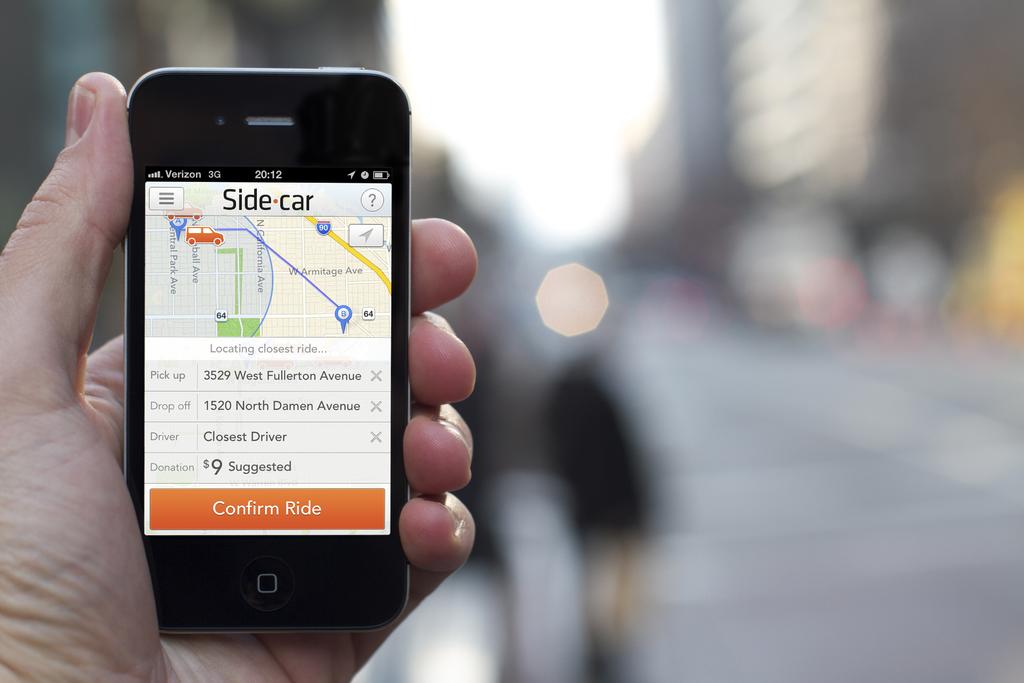What app are they using?
Offer a terse response. Side car. What does the orange bar say?
Make the answer very short. Confirm ride. 